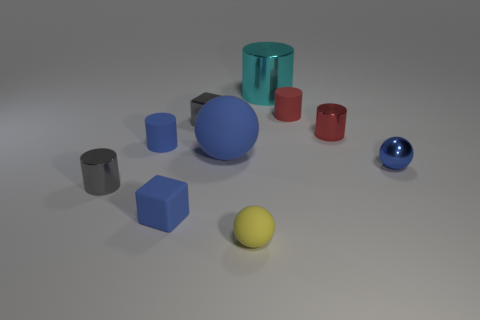There is a blue block that is the same size as the red rubber thing; what is it made of?
Give a very brief answer. Rubber. What is the color of the other matte thing that is the same shape as the yellow rubber thing?
Your answer should be very brief. Blue. There is a tiny blue object behind the tiny blue sphere; what is its shape?
Your answer should be very brief. Cylinder. What number of tiny red objects are the same shape as the large blue matte object?
Your answer should be very brief. 0. There is a block behind the tiny rubber block; does it have the same color as the small metallic thing that is on the left side of the tiny gray shiny cube?
Your answer should be very brief. Yes. What number of objects are either small blue shiny spheres or yellow metal blocks?
Ensure brevity in your answer.  1. What number of other yellow spheres have the same material as the large ball?
Give a very brief answer. 1. Are there fewer blue things than blue rubber blocks?
Give a very brief answer. No. Is the material of the small gray object that is in front of the big matte thing the same as the tiny blue sphere?
Make the answer very short. Yes. How many cylinders are large blue matte things or metallic objects?
Provide a succinct answer. 3. 